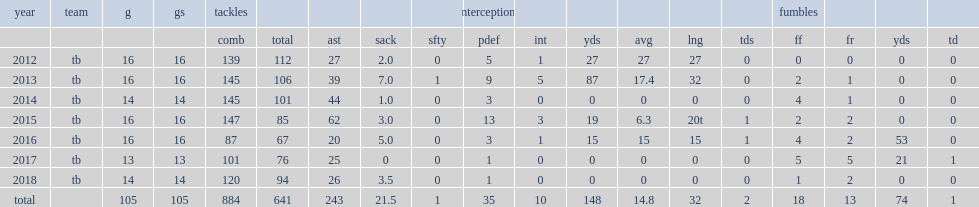How many ints did lavonte david get in 2015? 3.0. 